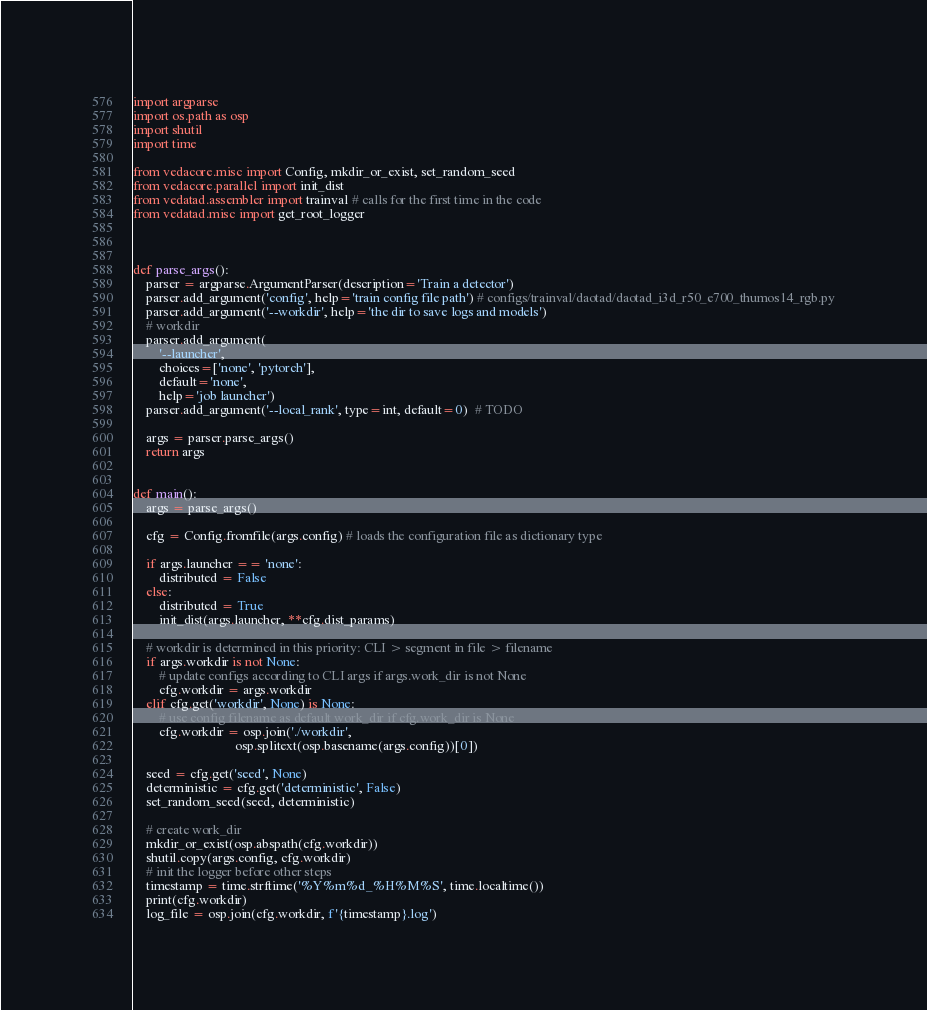<code> <loc_0><loc_0><loc_500><loc_500><_Python_>import argparse
import os.path as osp
import shutil
import time

from vedacore.misc import Config, mkdir_or_exist, set_random_seed
from vedacore.parallel import init_dist
from vedatad.assembler import trainval # calls for the first time in the code
from vedatad.misc import get_root_logger



def parse_args():
    parser = argparse.ArgumentParser(description='Train a detector')
    parser.add_argument('config', help='train config file path') # configs/trainval/daotad/daotad_i3d_r50_e700_thumos14_rgb.py
    parser.add_argument('--workdir', help='the dir to save logs and models')
    # workdir
    parser.add_argument(
        '--launcher',
        choices=['none', 'pytorch'],
        default='none',
        help='job launcher')
    parser.add_argument('--local_rank', type=int, default=0)  # TODO

    args = parser.parse_args()
    return args


def main():
    args = parse_args()

    cfg = Config.fromfile(args.config) # loads the configuration file as dictionary type

    if args.launcher == 'none':
        distributed = False
    else:
        distributed = True
        init_dist(args.launcher, **cfg.dist_params)

    # workdir is determined in this priority: CLI > segment in file > filename
    if args.workdir is not None:
        # update configs according to CLI args if args.work_dir is not None
        cfg.workdir = args.workdir
    elif cfg.get('workdir', None) is None:
        # use config filename as default work_dir if cfg.work_dir is None
        cfg.workdir = osp.join('./workdir',
                               osp.splitext(osp.basename(args.config))[0])

    seed = cfg.get('seed', None)
    deterministic = cfg.get('deterministic', False)
    set_random_seed(seed, deterministic)

    # create work_dir
    mkdir_or_exist(osp.abspath(cfg.workdir))
    shutil.copy(args.config, cfg.workdir)
    # init the logger before other steps
    timestamp = time.strftime('%Y%m%d_%H%M%S', time.localtime())
    print(cfg.workdir)
    log_file = osp.join(cfg.workdir, f'{timestamp}.log')</code> 